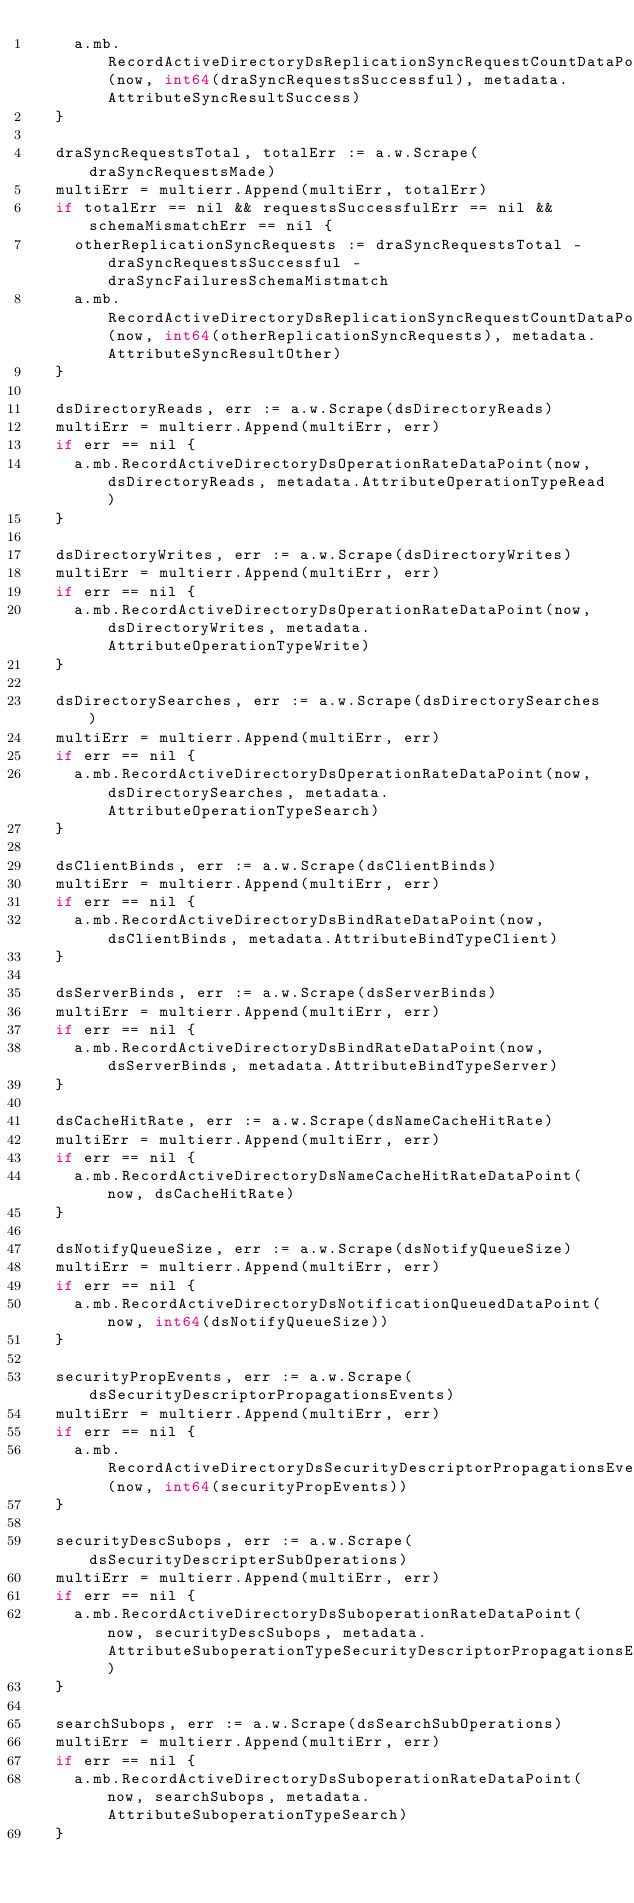<code> <loc_0><loc_0><loc_500><loc_500><_Go_>		a.mb.RecordActiveDirectoryDsReplicationSyncRequestCountDataPoint(now, int64(draSyncRequestsSuccessful), metadata.AttributeSyncResultSuccess)
	}

	draSyncRequestsTotal, totalErr := a.w.Scrape(draSyncRequestsMade)
	multiErr = multierr.Append(multiErr, totalErr)
	if totalErr == nil && requestsSuccessfulErr == nil && schemaMismatchErr == nil {
		otherReplicationSyncRequests := draSyncRequestsTotal - draSyncRequestsSuccessful - draSyncFailuresSchemaMistmatch
		a.mb.RecordActiveDirectoryDsReplicationSyncRequestCountDataPoint(now, int64(otherReplicationSyncRequests), metadata.AttributeSyncResultOther)
	}

	dsDirectoryReads, err := a.w.Scrape(dsDirectoryReads)
	multiErr = multierr.Append(multiErr, err)
	if err == nil {
		a.mb.RecordActiveDirectoryDsOperationRateDataPoint(now, dsDirectoryReads, metadata.AttributeOperationTypeRead)
	}

	dsDirectoryWrites, err := a.w.Scrape(dsDirectoryWrites)
	multiErr = multierr.Append(multiErr, err)
	if err == nil {
		a.mb.RecordActiveDirectoryDsOperationRateDataPoint(now, dsDirectoryWrites, metadata.AttributeOperationTypeWrite)
	}

	dsDirectorySearches, err := a.w.Scrape(dsDirectorySearches)
	multiErr = multierr.Append(multiErr, err)
	if err == nil {
		a.mb.RecordActiveDirectoryDsOperationRateDataPoint(now, dsDirectorySearches, metadata.AttributeOperationTypeSearch)
	}

	dsClientBinds, err := a.w.Scrape(dsClientBinds)
	multiErr = multierr.Append(multiErr, err)
	if err == nil {
		a.mb.RecordActiveDirectoryDsBindRateDataPoint(now, dsClientBinds, metadata.AttributeBindTypeClient)
	}

	dsServerBinds, err := a.w.Scrape(dsServerBinds)
	multiErr = multierr.Append(multiErr, err)
	if err == nil {
		a.mb.RecordActiveDirectoryDsBindRateDataPoint(now, dsServerBinds, metadata.AttributeBindTypeServer)
	}

	dsCacheHitRate, err := a.w.Scrape(dsNameCacheHitRate)
	multiErr = multierr.Append(multiErr, err)
	if err == nil {
		a.mb.RecordActiveDirectoryDsNameCacheHitRateDataPoint(now, dsCacheHitRate)
	}

	dsNotifyQueueSize, err := a.w.Scrape(dsNotifyQueueSize)
	multiErr = multierr.Append(multiErr, err)
	if err == nil {
		a.mb.RecordActiveDirectoryDsNotificationQueuedDataPoint(now, int64(dsNotifyQueueSize))
	}

	securityPropEvents, err := a.w.Scrape(dsSecurityDescriptorPropagationsEvents)
	multiErr = multierr.Append(multiErr, err)
	if err == nil {
		a.mb.RecordActiveDirectoryDsSecurityDescriptorPropagationsEventQueuedDataPoint(now, int64(securityPropEvents))
	}

	securityDescSubops, err := a.w.Scrape(dsSecurityDescripterSubOperations)
	multiErr = multierr.Append(multiErr, err)
	if err == nil {
		a.mb.RecordActiveDirectoryDsSuboperationRateDataPoint(now, securityDescSubops, metadata.AttributeSuboperationTypeSecurityDescriptorPropagationsEvent)
	}

	searchSubops, err := a.w.Scrape(dsSearchSubOperations)
	multiErr = multierr.Append(multiErr, err)
	if err == nil {
		a.mb.RecordActiveDirectoryDsSuboperationRateDataPoint(now, searchSubops, metadata.AttributeSuboperationTypeSearch)
	}
</code> 